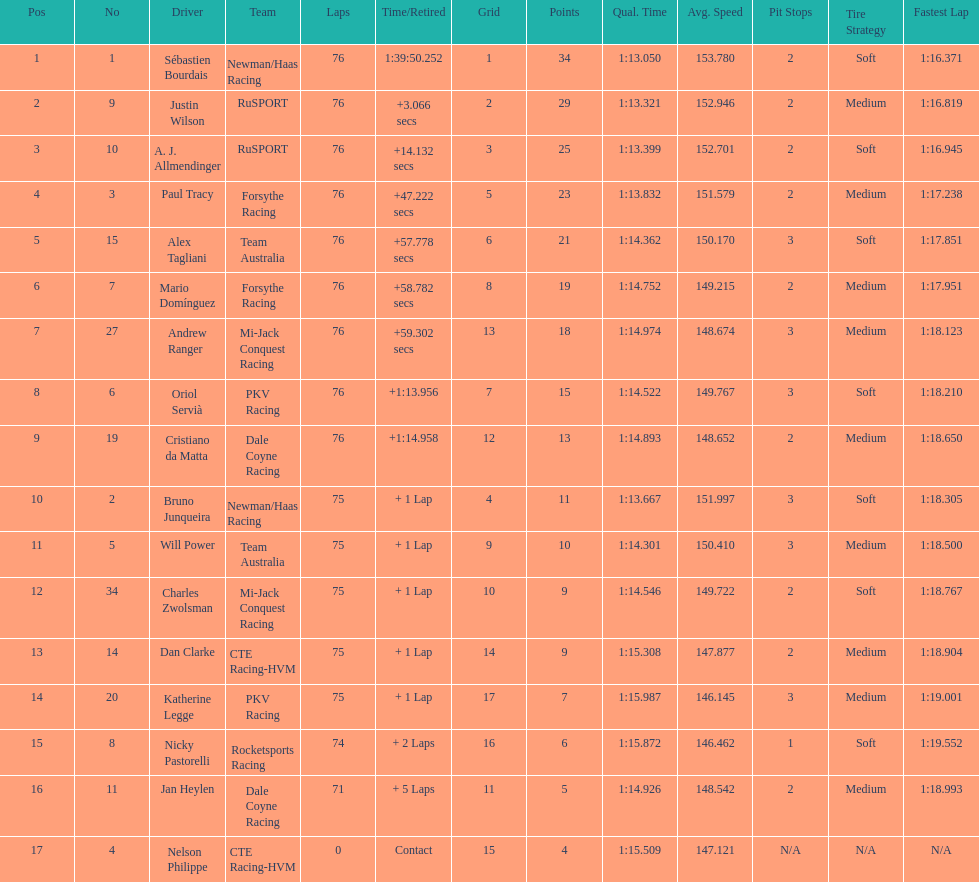What is the total point difference between the driver who received the most points and the driver who received the least? 30. 